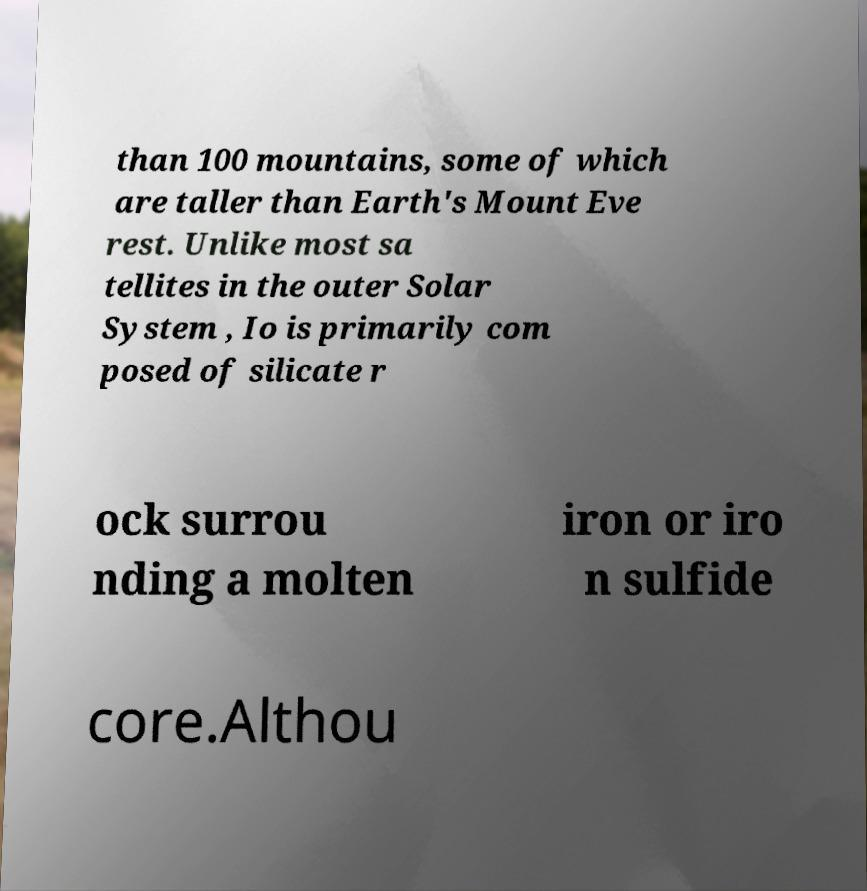Can you accurately transcribe the text from the provided image for me? than 100 mountains, some of which are taller than Earth's Mount Eve rest. Unlike most sa tellites in the outer Solar System , Io is primarily com posed of silicate r ock surrou nding a molten iron or iro n sulfide core.Althou 